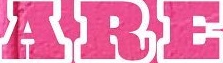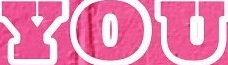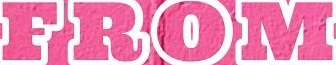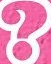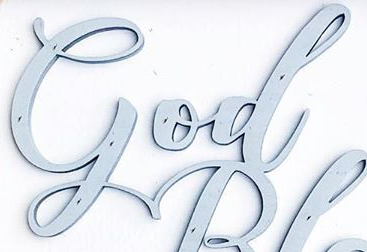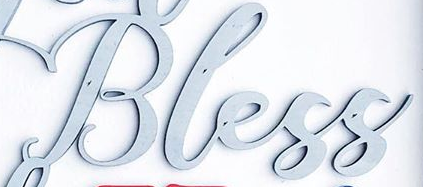What words are shown in these images in order, separated by a semicolon? ARE; YOU; FROM; ?; God; Bless 